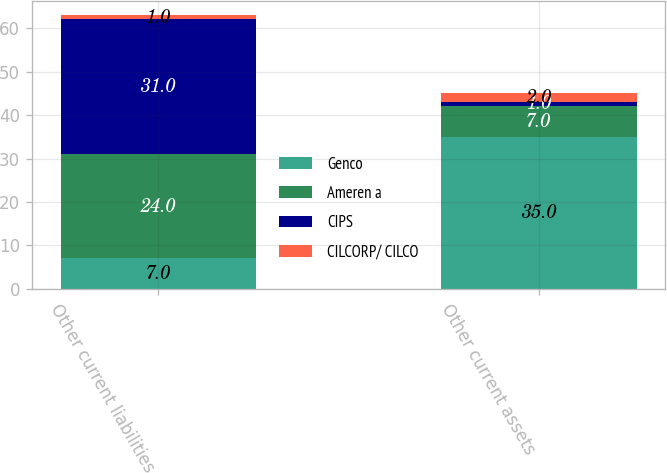Convert chart to OTSL. <chart><loc_0><loc_0><loc_500><loc_500><stacked_bar_chart><ecel><fcel>Other current liabilities<fcel>Other current assets<nl><fcel>Genco<fcel>7<fcel>35<nl><fcel>Ameren a<fcel>24<fcel>7<nl><fcel>CIPS<fcel>31<fcel>1<nl><fcel>CILCORP/ CILCO<fcel>1<fcel>2<nl></chart> 